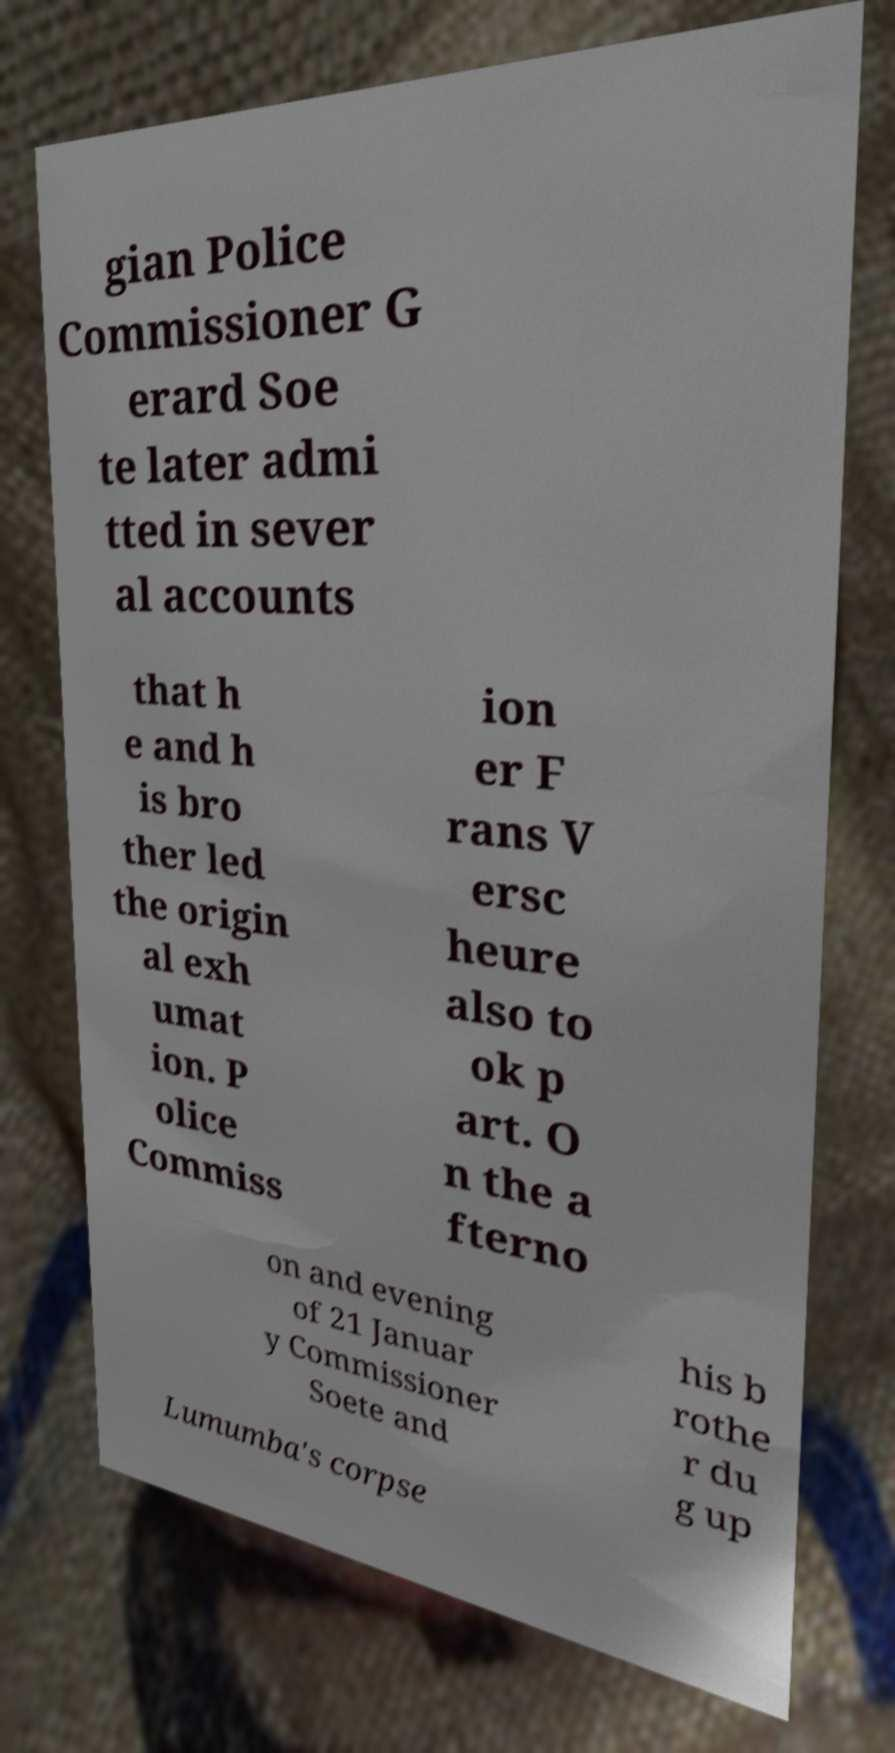Can you read and provide the text displayed in the image?This photo seems to have some interesting text. Can you extract and type it out for me? gian Police Commissioner G erard Soe te later admi tted in sever al accounts that h e and h is bro ther led the origin al exh umat ion. P olice Commiss ion er F rans V ersc heure also to ok p art. O n the a fterno on and evening of 21 Januar y Commissioner Soete and his b rothe r du g up Lumumba's corpse 